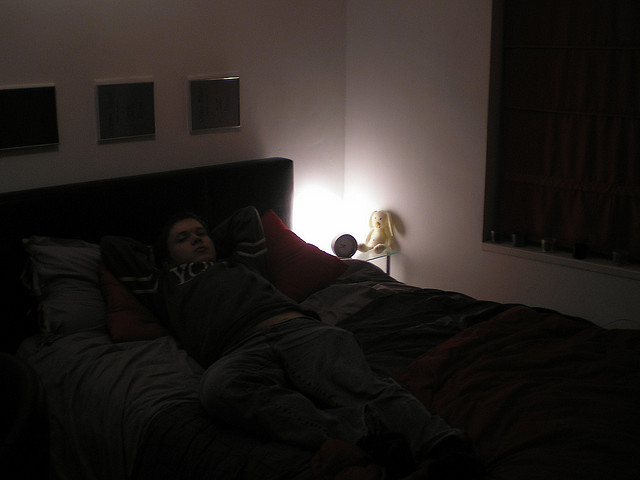<image>What type of animal is in the picture? I am not sure what type of animal is in the picture. It can be a dog, bunny, or there might be no animal at all. What type of animal is in the picture? I don't know what type of animal is in the picture. It can be a human, a dog, a bunny, or a rabbit. 